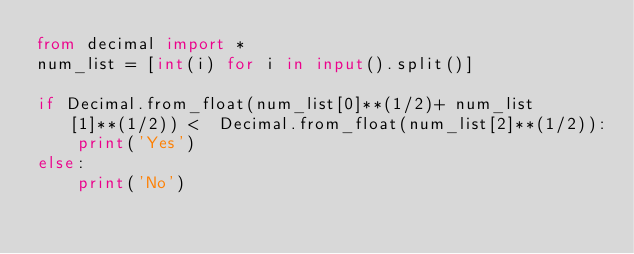Convert code to text. <code><loc_0><loc_0><loc_500><loc_500><_Python_>from decimal import *
num_list = [int(i) for i in input().split()]

if Decimal.from_float(num_list[0]**(1/2)+ num_list[1]**(1/2)) <  Decimal.from_float(num_list[2]**(1/2)):
    print('Yes')
else:
    print('No')</code> 